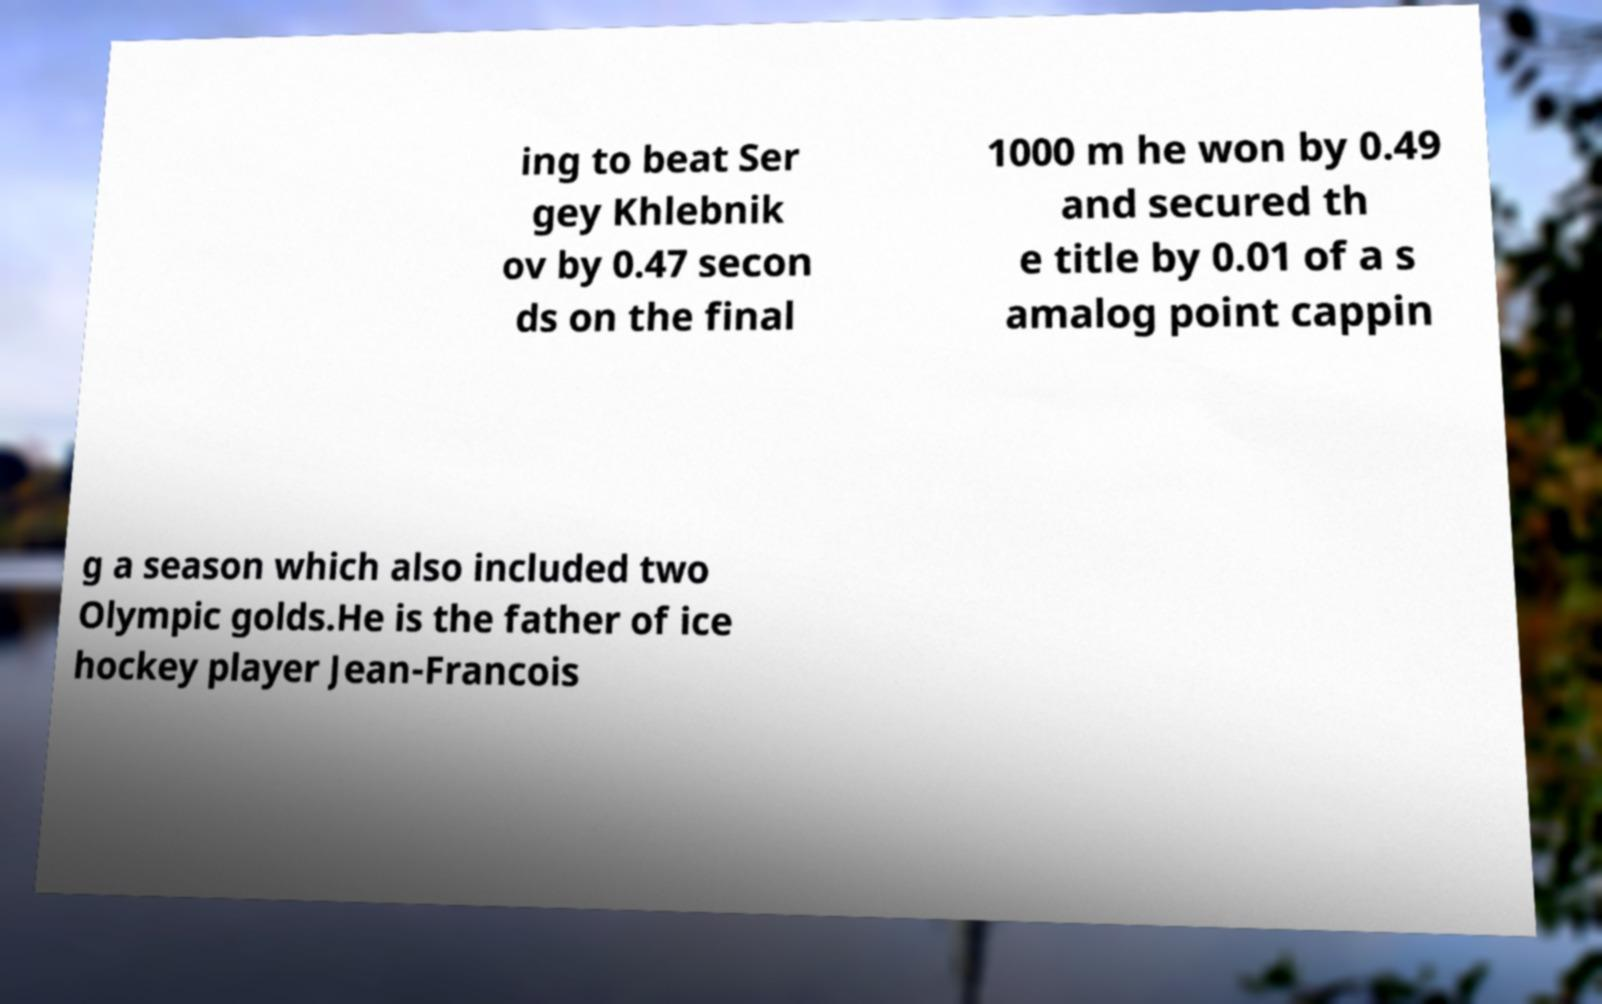Can you accurately transcribe the text from the provided image for me? ing to beat Ser gey Khlebnik ov by 0.47 secon ds on the final 1000 m he won by 0.49 and secured th e title by 0.01 of a s amalog point cappin g a season which also included two Olympic golds.He is the father of ice hockey player Jean-Francois 